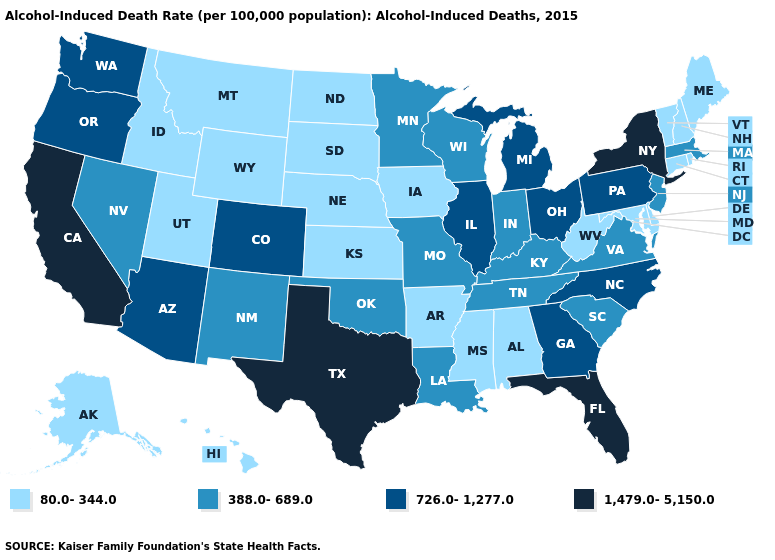Name the states that have a value in the range 726.0-1,277.0?
Write a very short answer. Arizona, Colorado, Georgia, Illinois, Michigan, North Carolina, Ohio, Oregon, Pennsylvania, Washington. Among the states that border Washington , does Idaho have the lowest value?
Quick response, please. Yes. Does Florida have the highest value in the USA?
Short answer required. Yes. What is the highest value in the South ?
Answer briefly. 1,479.0-5,150.0. What is the value of Illinois?
Keep it brief. 726.0-1,277.0. Name the states that have a value in the range 1,479.0-5,150.0?
Short answer required. California, Florida, New York, Texas. Among the states that border New Hampshire , does Massachusetts have the highest value?
Keep it brief. Yes. What is the lowest value in the USA?
Give a very brief answer. 80.0-344.0. Does Texas have the highest value in the USA?
Quick response, please. Yes. Does the first symbol in the legend represent the smallest category?
Short answer required. Yes. Name the states that have a value in the range 726.0-1,277.0?
Write a very short answer. Arizona, Colorado, Georgia, Illinois, Michigan, North Carolina, Ohio, Oregon, Pennsylvania, Washington. Does Ohio have the lowest value in the USA?
Keep it brief. No. Does the map have missing data?
Answer briefly. No. Which states hav the highest value in the Northeast?
Answer briefly. New York. What is the value of Tennessee?
Keep it brief. 388.0-689.0. 